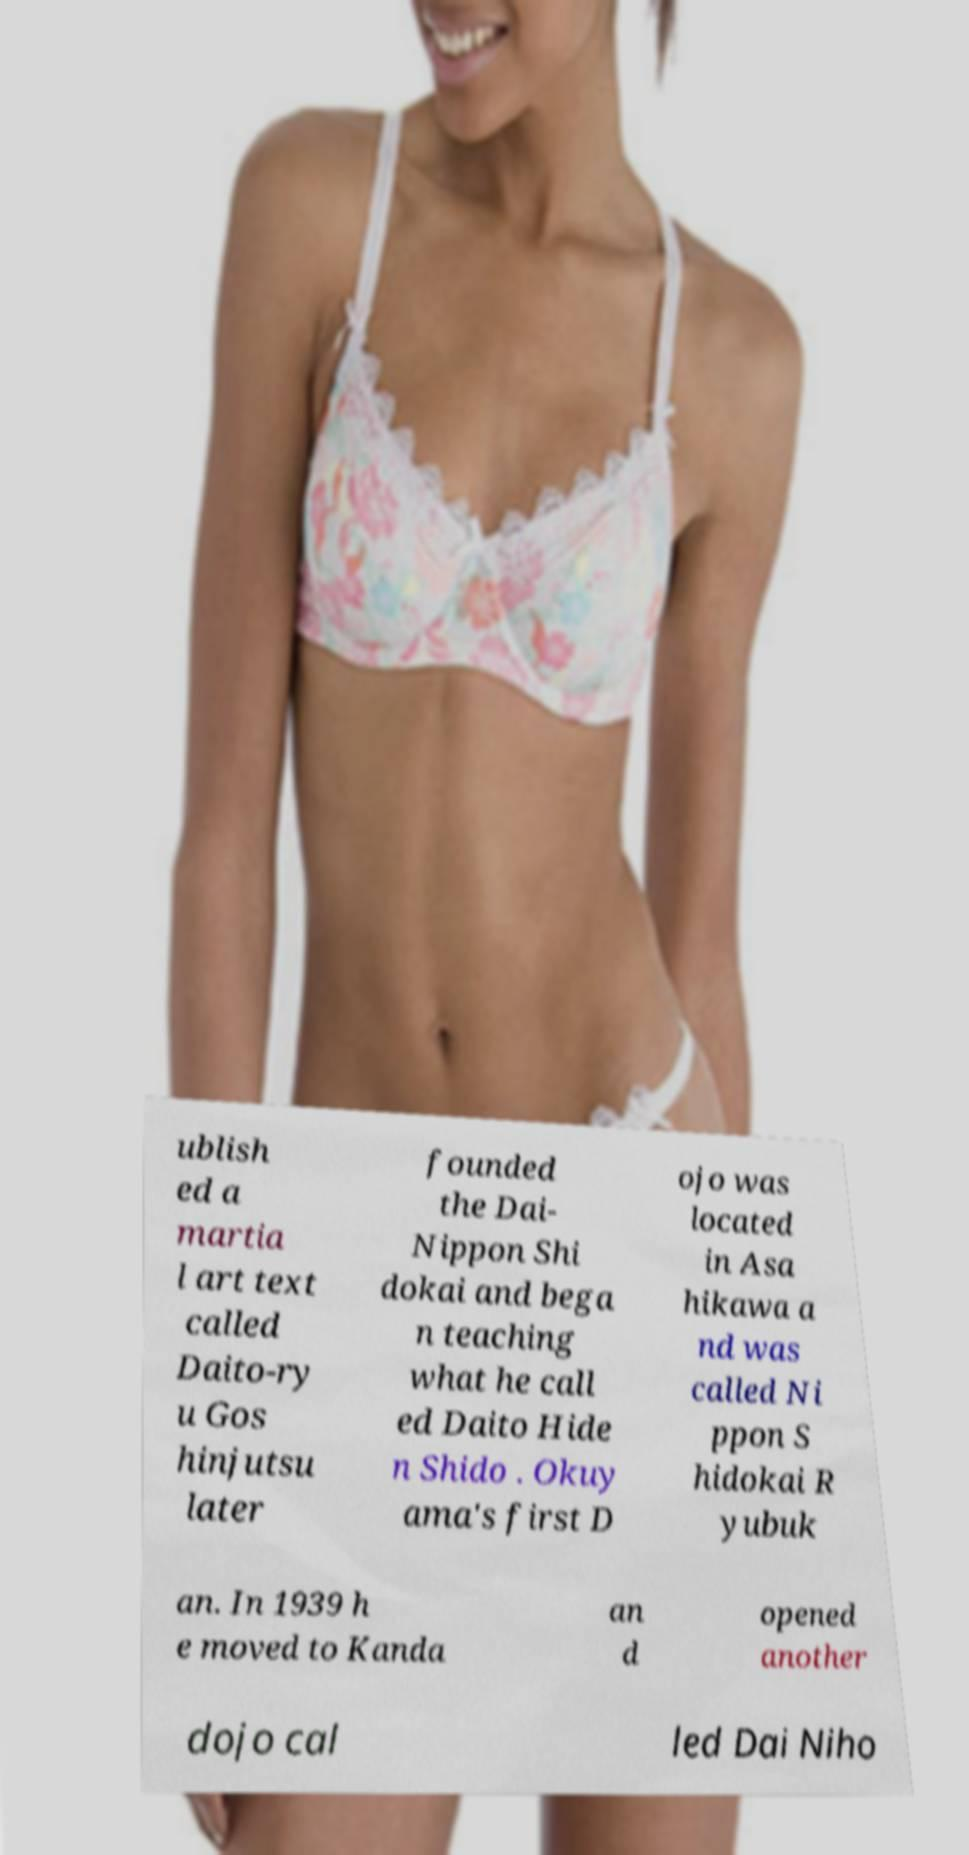Please identify and transcribe the text found in this image. ublish ed a martia l art text called Daito-ry u Gos hinjutsu later founded the Dai- Nippon Shi dokai and bega n teaching what he call ed Daito Hide n Shido . Okuy ama's first D ojo was located in Asa hikawa a nd was called Ni ppon S hidokai R yubuk an. In 1939 h e moved to Kanda an d opened another dojo cal led Dai Niho 